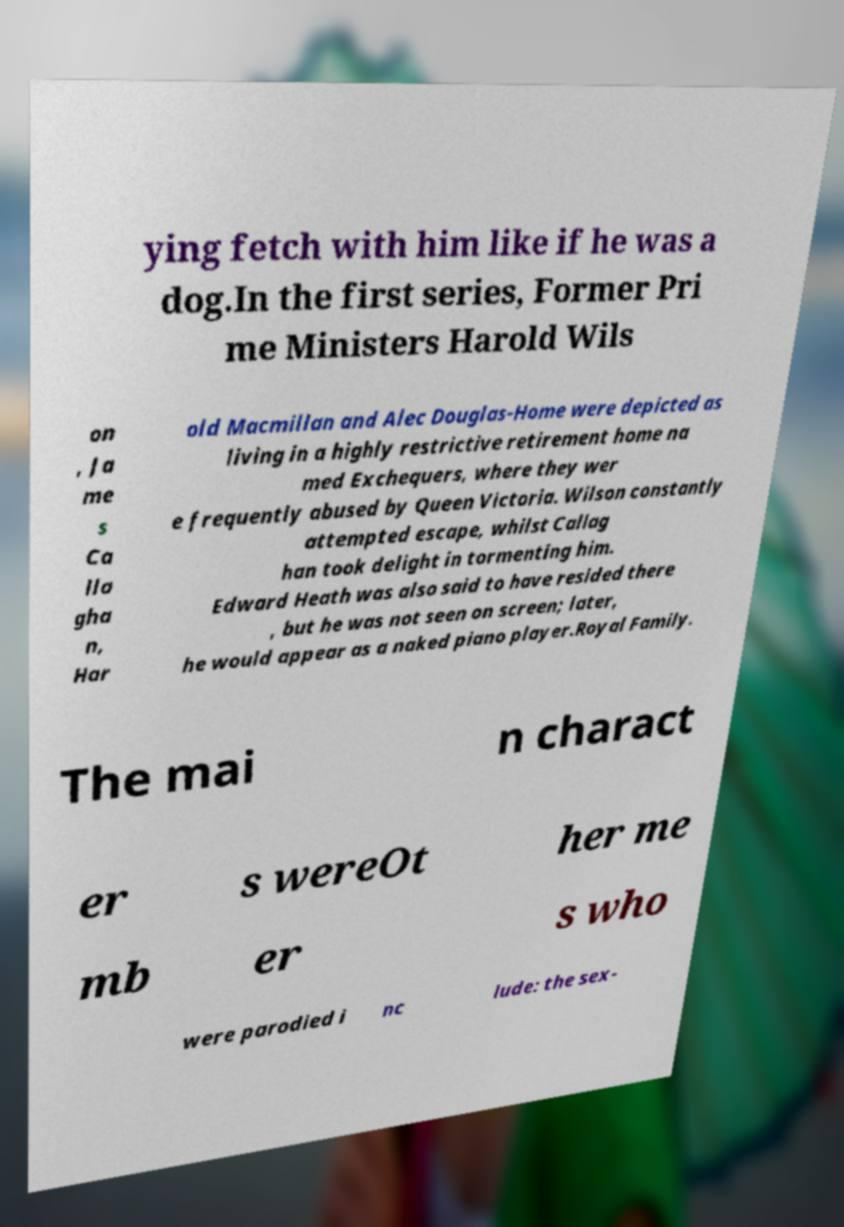Could you extract and type out the text from this image? ying fetch with him like if he was a dog.In the first series, Former Pri me Ministers Harold Wils on , Ja me s Ca lla gha n, Har old Macmillan and Alec Douglas-Home were depicted as living in a highly restrictive retirement home na med Exchequers, where they wer e frequently abused by Queen Victoria. Wilson constantly attempted escape, whilst Callag han took delight in tormenting him. Edward Heath was also said to have resided there , but he was not seen on screen; later, he would appear as a naked piano player.Royal Family. The mai n charact er s wereOt her me mb er s who were parodied i nc lude: the sex- 